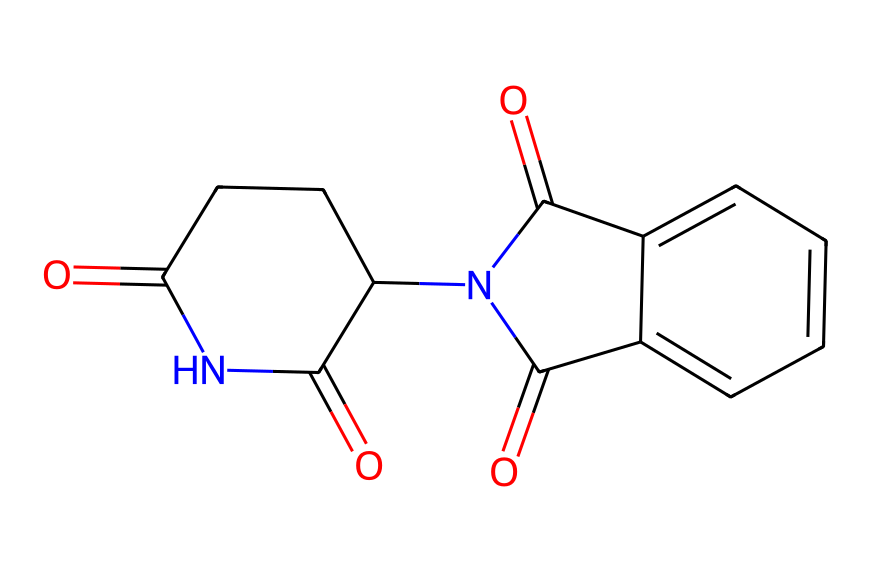What is the molecular formula of thalidomide? To find the molecular formula, count the number of each type of atom represented in the SMILES. In the SMILES, there are 13 carbon (C) atoms, 10 hydrogen (H) atoms, 4 oxygen (O) atoms, and 2 nitrogen (N) atoms, which gives the formula C13H10N2O4.
Answer: C13H10N2O4 How many rings are present in thalidomide? By analyzing the SMILES, we can see that there are two cyclic structures indicated, one is a five-membered ring (C1CCC) and the other is part of the fused structure with the nitrogen and carbonyl groups. Together, this indicates two rings.
Answer: 2 What functional groups can be identified in thalidomide? Based on the SMILES, we can identify carbonyl groups (C=O) and an amide (C(=O)N) structure. This indicates the presence of both ketones and amides in the molecule.
Answer: carbonyl and amide Is thalidomide a chiral compound? The presence of a carbon atom bonded to four different groups (as indicated in the structure) makes it a chiral compound, leading to non-superimposable mirror images.
Answer: Yes How many stereocenters are there in thalidomide? To determine the number of stereocenters, we look for carbon atoms connected to four different groups. In this compound, there is one stereocenter located in the cyclic structure, thus there is only one stereocenter present.
Answer: 1 What is the historical significance of thalidomide? Thalidomide is historically significant due to its use as a sedative and the subsequent birth defects associated with its use during pregnancy, leading to increased regulations in pharmaceutical safety.
Answer: Birth defects 